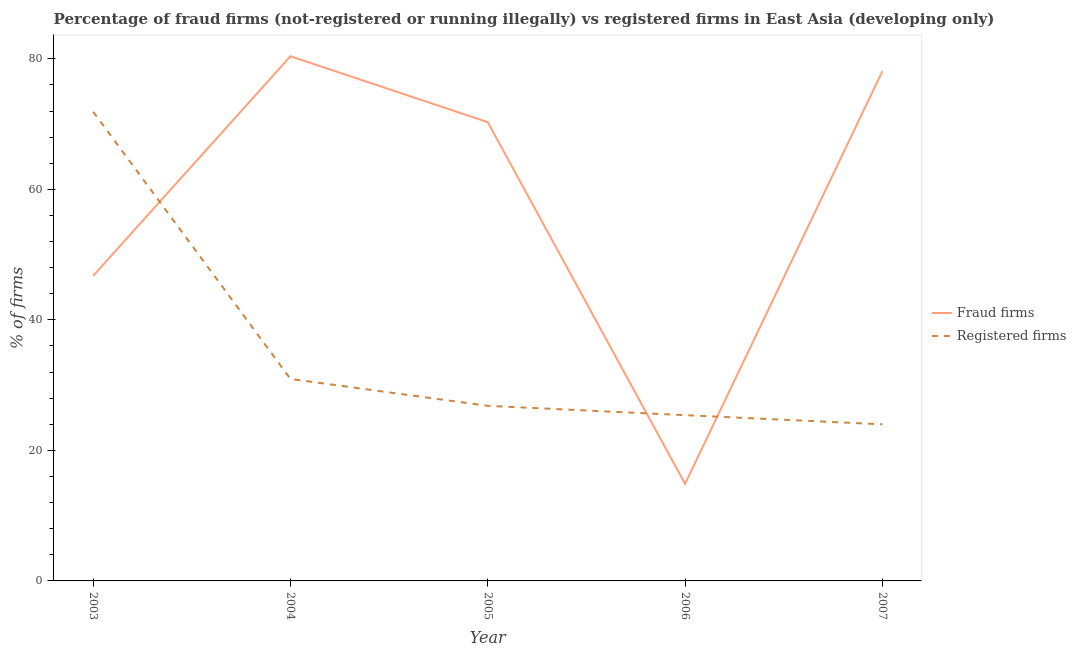How many different coloured lines are there?
Your answer should be compact. 2. Is the number of lines equal to the number of legend labels?
Give a very brief answer. Yes. What is the percentage of fraud firms in 2003?
Give a very brief answer. 46.74. Across all years, what is the maximum percentage of fraud firms?
Your answer should be compact. 80.4. Across all years, what is the minimum percentage of fraud firms?
Your answer should be very brief. 14.88. What is the total percentage of fraud firms in the graph?
Offer a very short reply. 290.44. What is the difference between the percentage of registered firms in 2003 and that in 2006?
Ensure brevity in your answer.  46.5. What is the difference between the percentage of fraud firms in 2004 and the percentage of registered firms in 2007?
Provide a short and direct response. 56.4. What is the average percentage of registered firms per year?
Ensure brevity in your answer.  35.82. In the year 2004, what is the difference between the percentage of registered firms and percentage of fraud firms?
Offer a terse response. -49.45. What is the ratio of the percentage of fraud firms in 2003 to that in 2004?
Your response must be concise. 0.58. Is the percentage of fraud firms in 2004 less than that in 2005?
Your answer should be very brief. No. What is the difference between the highest and the second highest percentage of registered firms?
Offer a very short reply. 40.95. What is the difference between the highest and the lowest percentage of registered firms?
Your answer should be very brief. 47.9. Is the sum of the percentage of registered firms in 2004 and 2005 greater than the maximum percentage of fraud firms across all years?
Keep it short and to the point. No. Does the percentage of registered firms monotonically increase over the years?
Provide a succinct answer. No. Is the percentage of fraud firms strictly less than the percentage of registered firms over the years?
Provide a succinct answer. No. How many lines are there?
Ensure brevity in your answer.  2. How many years are there in the graph?
Provide a short and direct response. 5. What is the difference between two consecutive major ticks on the Y-axis?
Give a very brief answer. 20. Are the values on the major ticks of Y-axis written in scientific E-notation?
Your response must be concise. No. Does the graph contain any zero values?
Give a very brief answer. No. How many legend labels are there?
Your answer should be compact. 2. How are the legend labels stacked?
Your answer should be very brief. Vertical. What is the title of the graph?
Make the answer very short. Percentage of fraud firms (not-registered or running illegally) vs registered firms in East Asia (developing only). Does "Age 15+" appear as one of the legend labels in the graph?
Give a very brief answer. No. What is the label or title of the X-axis?
Give a very brief answer. Year. What is the label or title of the Y-axis?
Provide a short and direct response. % of firms. What is the % of firms of Fraud firms in 2003?
Give a very brief answer. 46.74. What is the % of firms in Registered firms in 2003?
Offer a terse response. 71.9. What is the % of firms of Fraud firms in 2004?
Provide a succinct answer. 80.4. What is the % of firms in Registered firms in 2004?
Your answer should be compact. 30.95. What is the % of firms of Fraud firms in 2005?
Give a very brief answer. 70.3. What is the % of firms of Registered firms in 2005?
Ensure brevity in your answer.  26.83. What is the % of firms of Fraud firms in 2006?
Give a very brief answer. 14.88. What is the % of firms of Registered firms in 2006?
Ensure brevity in your answer.  25.4. What is the % of firms of Fraud firms in 2007?
Provide a succinct answer. 78.11. What is the % of firms of Registered firms in 2007?
Offer a very short reply. 24. Across all years, what is the maximum % of firms of Fraud firms?
Make the answer very short. 80.4. Across all years, what is the maximum % of firms of Registered firms?
Offer a very short reply. 71.9. Across all years, what is the minimum % of firms of Fraud firms?
Ensure brevity in your answer.  14.88. What is the total % of firms of Fraud firms in the graph?
Your answer should be very brief. 290.44. What is the total % of firms in Registered firms in the graph?
Offer a terse response. 179.08. What is the difference between the % of firms of Fraud firms in 2003 and that in 2004?
Make the answer very short. -33.66. What is the difference between the % of firms of Registered firms in 2003 and that in 2004?
Offer a terse response. 40.95. What is the difference between the % of firms in Fraud firms in 2003 and that in 2005?
Make the answer very short. -23.55. What is the difference between the % of firms in Registered firms in 2003 and that in 2005?
Your response must be concise. 45.07. What is the difference between the % of firms in Fraud firms in 2003 and that in 2006?
Offer a terse response. 31.86. What is the difference between the % of firms in Registered firms in 2003 and that in 2006?
Give a very brief answer. 46.5. What is the difference between the % of firms of Fraud firms in 2003 and that in 2007?
Your response must be concise. -31.36. What is the difference between the % of firms in Registered firms in 2003 and that in 2007?
Make the answer very short. 47.9. What is the difference between the % of firms in Fraud firms in 2004 and that in 2005?
Make the answer very short. 10.1. What is the difference between the % of firms in Registered firms in 2004 and that in 2005?
Your answer should be compact. 4.12. What is the difference between the % of firms in Fraud firms in 2004 and that in 2006?
Give a very brief answer. 65.52. What is the difference between the % of firms in Registered firms in 2004 and that in 2006?
Provide a succinct answer. 5.55. What is the difference between the % of firms of Fraud firms in 2004 and that in 2007?
Your answer should be compact. 2.29. What is the difference between the % of firms in Registered firms in 2004 and that in 2007?
Your response must be concise. 6.95. What is the difference between the % of firms of Fraud firms in 2005 and that in 2006?
Keep it short and to the point. 55.42. What is the difference between the % of firms of Registered firms in 2005 and that in 2006?
Provide a succinct answer. 1.43. What is the difference between the % of firms in Fraud firms in 2005 and that in 2007?
Give a very brief answer. -7.81. What is the difference between the % of firms in Registered firms in 2005 and that in 2007?
Your response must be concise. 2.83. What is the difference between the % of firms in Fraud firms in 2006 and that in 2007?
Give a very brief answer. -63.23. What is the difference between the % of firms in Registered firms in 2006 and that in 2007?
Provide a short and direct response. 1.4. What is the difference between the % of firms in Fraud firms in 2003 and the % of firms in Registered firms in 2004?
Offer a very short reply. 15.79. What is the difference between the % of firms of Fraud firms in 2003 and the % of firms of Registered firms in 2005?
Provide a succinct answer. 19.91. What is the difference between the % of firms in Fraud firms in 2003 and the % of firms in Registered firms in 2006?
Give a very brief answer. 21.34. What is the difference between the % of firms of Fraud firms in 2003 and the % of firms of Registered firms in 2007?
Ensure brevity in your answer.  22.75. What is the difference between the % of firms of Fraud firms in 2004 and the % of firms of Registered firms in 2005?
Provide a short and direct response. 53.57. What is the difference between the % of firms of Fraud firms in 2004 and the % of firms of Registered firms in 2007?
Your answer should be very brief. 56.4. What is the difference between the % of firms in Fraud firms in 2005 and the % of firms in Registered firms in 2006?
Offer a very short reply. 44.9. What is the difference between the % of firms of Fraud firms in 2005 and the % of firms of Registered firms in 2007?
Offer a terse response. 46.3. What is the difference between the % of firms in Fraud firms in 2006 and the % of firms in Registered firms in 2007?
Your response must be concise. -9.12. What is the average % of firms in Fraud firms per year?
Offer a terse response. 58.09. What is the average % of firms in Registered firms per year?
Keep it short and to the point. 35.82. In the year 2003, what is the difference between the % of firms in Fraud firms and % of firms in Registered firms?
Make the answer very short. -25.16. In the year 2004, what is the difference between the % of firms of Fraud firms and % of firms of Registered firms?
Keep it short and to the point. 49.45. In the year 2005, what is the difference between the % of firms of Fraud firms and % of firms of Registered firms?
Keep it short and to the point. 43.47. In the year 2006, what is the difference between the % of firms in Fraud firms and % of firms in Registered firms?
Your answer should be very brief. -10.52. In the year 2007, what is the difference between the % of firms of Fraud firms and % of firms of Registered firms?
Ensure brevity in your answer.  54.11. What is the ratio of the % of firms in Fraud firms in 2003 to that in 2004?
Ensure brevity in your answer.  0.58. What is the ratio of the % of firms of Registered firms in 2003 to that in 2004?
Keep it short and to the point. 2.32. What is the ratio of the % of firms of Fraud firms in 2003 to that in 2005?
Provide a short and direct response. 0.66. What is the ratio of the % of firms in Registered firms in 2003 to that in 2005?
Your answer should be very brief. 2.68. What is the ratio of the % of firms of Fraud firms in 2003 to that in 2006?
Offer a terse response. 3.14. What is the ratio of the % of firms in Registered firms in 2003 to that in 2006?
Your response must be concise. 2.83. What is the ratio of the % of firms in Fraud firms in 2003 to that in 2007?
Ensure brevity in your answer.  0.6. What is the ratio of the % of firms in Registered firms in 2003 to that in 2007?
Offer a very short reply. 3. What is the ratio of the % of firms in Fraud firms in 2004 to that in 2005?
Ensure brevity in your answer.  1.14. What is the ratio of the % of firms of Registered firms in 2004 to that in 2005?
Keep it short and to the point. 1.15. What is the ratio of the % of firms in Fraud firms in 2004 to that in 2006?
Offer a terse response. 5.4. What is the ratio of the % of firms of Registered firms in 2004 to that in 2006?
Offer a very short reply. 1.22. What is the ratio of the % of firms of Fraud firms in 2004 to that in 2007?
Your answer should be compact. 1.03. What is the ratio of the % of firms of Registered firms in 2004 to that in 2007?
Your answer should be compact. 1.29. What is the ratio of the % of firms of Fraud firms in 2005 to that in 2006?
Keep it short and to the point. 4.72. What is the ratio of the % of firms of Registered firms in 2005 to that in 2006?
Provide a succinct answer. 1.06. What is the ratio of the % of firms in Registered firms in 2005 to that in 2007?
Offer a terse response. 1.12. What is the ratio of the % of firms in Fraud firms in 2006 to that in 2007?
Provide a succinct answer. 0.19. What is the ratio of the % of firms in Registered firms in 2006 to that in 2007?
Your answer should be compact. 1.06. What is the difference between the highest and the second highest % of firms in Fraud firms?
Provide a succinct answer. 2.29. What is the difference between the highest and the second highest % of firms in Registered firms?
Your answer should be compact. 40.95. What is the difference between the highest and the lowest % of firms in Fraud firms?
Provide a short and direct response. 65.52. What is the difference between the highest and the lowest % of firms of Registered firms?
Provide a short and direct response. 47.9. 